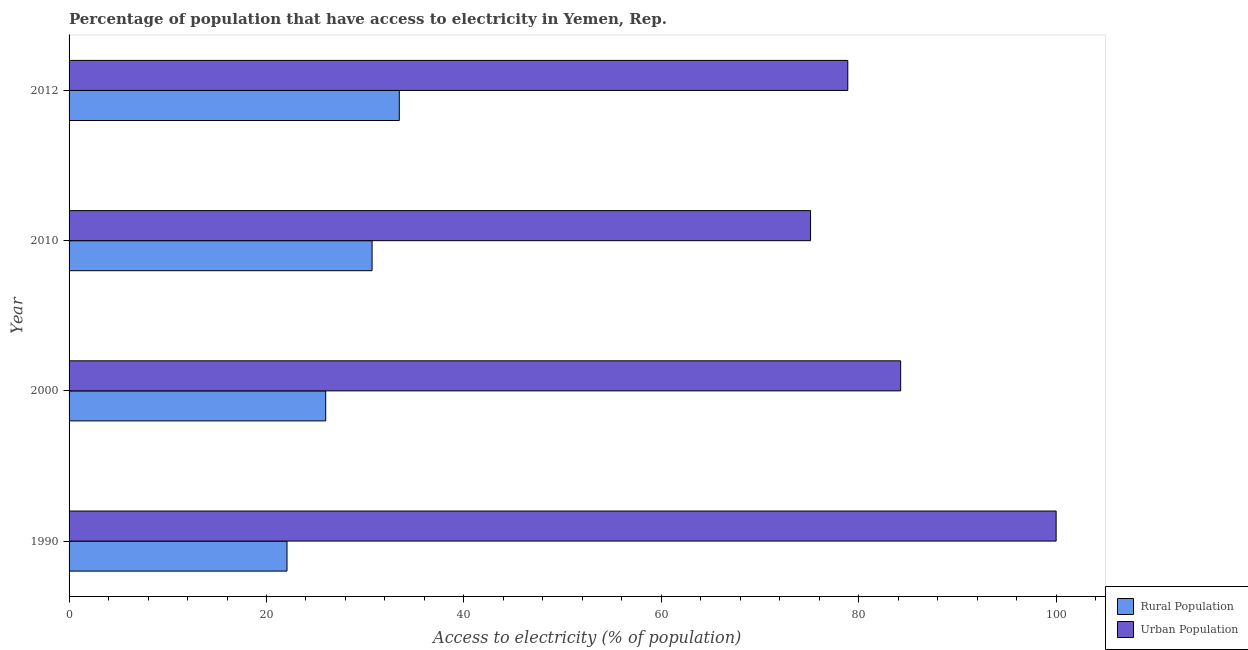How many different coloured bars are there?
Give a very brief answer. 2. How many groups of bars are there?
Offer a very short reply. 4. Are the number of bars per tick equal to the number of legend labels?
Your answer should be very brief. Yes. How many bars are there on the 3rd tick from the bottom?
Your answer should be compact. 2. What is the label of the 1st group of bars from the top?
Your answer should be very brief. 2012. What is the percentage of urban population having access to electricity in 2010?
Offer a very short reply. 75.12. Across all years, what is the maximum percentage of urban population having access to electricity?
Offer a very short reply. 100. Across all years, what is the minimum percentage of rural population having access to electricity?
Provide a succinct answer. 22.08. What is the total percentage of urban population having access to electricity in the graph?
Keep it short and to the point. 338.26. What is the difference between the percentage of urban population having access to electricity in 2010 and that in 2012?
Ensure brevity in your answer.  -3.77. What is the difference between the percentage of rural population having access to electricity in 2000 and the percentage of urban population having access to electricity in 1990?
Your answer should be compact. -74. What is the average percentage of urban population having access to electricity per year?
Offer a terse response. 84.56. In the year 2012, what is the difference between the percentage of urban population having access to electricity and percentage of rural population having access to electricity?
Your answer should be compact. 45.44. In how many years, is the percentage of urban population having access to electricity greater than 84 %?
Your response must be concise. 2. What is the ratio of the percentage of rural population having access to electricity in 1990 to that in 2000?
Provide a succinct answer. 0.85. Is the difference between the percentage of urban population having access to electricity in 1990 and 2010 greater than the difference between the percentage of rural population having access to electricity in 1990 and 2010?
Offer a very short reply. Yes. What is the difference between the highest and the second highest percentage of rural population having access to electricity?
Offer a very short reply. 2.75. What is the difference between the highest and the lowest percentage of urban population having access to electricity?
Your answer should be compact. 24.88. Is the sum of the percentage of rural population having access to electricity in 1990 and 2010 greater than the maximum percentage of urban population having access to electricity across all years?
Your answer should be very brief. No. What does the 1st bar from the top in 1990 represents?
Give a very brief answer. Urban Population. What does the 1st bar from the bottom in 2012 represents?
Your answer should be very brief. Rural Population. How many bars are there?
Offer a terse response. 8. How many years are there in the graph?
Keep it short and to the point. 4. What is the difference between two consecutive major ticks on the X-axis?
Offer a very short reply. 20. Does the graph contain any zero values?
Offer a very short reply. No. Where does the legend appear in the graph?
Make the answer very short. Bottom right. How are the legend labels stacked?
Offer a terse response. Vertical. What is the title of the graph?
Keep it short and to the point. Percentage of population that have access to electricity in Yemen, Rep. Does "Subsidies" appear as one of the legend labels in the graph?
Give a very brief answer. No. What is the label or title of the X-axis?
Your answer should be very brief. Access to electricity (% of population). What is the Access to electricity (% of population) of Rural Population in 1990?
Give a very brief answer. 22.08. What is the Access to electricity (% of population) of Urban Population in 1990?
Make the answer very short. 100. What is the Access to electricity (% of population) of Urban Population in 2000?
Your response must be concise. 84.25. What is the Access to electricity (% of population) in Rural Population in 2010?
Give a very brief answer. 30.7. What is the Access to electricity (% of population) in Urban Population in 2010?
Provide a succinct answer. 75.12. What is the Access to electricity (% of population) of Rural Population in 2012?
Make the answer very short. 33.45. What is the Access to electricity (% of population) of Urban Population in 2012?
Offer a very short reply. 78.89. Across all years, what is the maximum Access to electricity (% of population) in Rural Population?
Give a very brief answer. 33.45. Across all years, what is the maximum Access to electricity (% of population) of Urban Population?
Offer a terse response. 100. Across all years, what is the minimum Access to electricity (% of population) in Rural Population?
Your answer should be compact. 22.08. Across all years, what is the minimum Access to electricity (% of population) in Urban Population?
Provide a short and direct response. 75.12. What is the total Access to electricity (% of population) of Rural Population in the graph?
Make the answer very short. 112.23. What is the total Access to electricity (% of population) in Urban Population in the graph?
Provide a succinct answer. 338.26. What is the difference between the Access to electricity (% of population) in Rural Population in 1990 and that in 2000?
Keep it short and to the point. -3.92. What is the difference between the Access to electricity (% of population) in Urban Population in 1990 and that in 2000?
Make the answer very short. 15.75. What is the difference between the Access to electricity (% of population) in Rural Population in 1990 and that in 2010?
Offer a very short reply. -8.62. What is the difference between the Access to electricity (% of population) of Urban Population in 1990 and that in 2010?
Ensure brevity in your answer.  24.88. What is the difference between the Access to electricity (% of population) in Rural Population in 1990 and that in 2012?
Your response must be concise. -11.38. What is the difference between the Access to electricity (% of population) in Urban Population in 1990 and that in 2012?
Offer a very short reply. 21.11. What is the difference between the Access to electricity (% of population) in Rural Population in 2000 and that in 2010?
Make the answer very short. -4.7. What is the difference between the Access to electricity (% of population) in Urban Population in 2000 and that in 2010?
Make the answer very short. 9.13. What is the difference between the Access to electricity (% of population) in Rural Population in 2000 and that in 2012?
Give a very brief answer. -7.45. What is the difference between the Access to electricity (% of population) of Urban Population in 2000 and that in 2012?
Your answer should be compact. 5.36. What is the difference between the Access to electricity (% of population) of Rural Population in 2010 and that in 2012?
Your answer should be compact. -2.75. What is the difference between the Access to electricity (% of population) of Urban Population in 2010 and that in 2012?
Offer a very short reply. -3.77. What is the difference between the Access to electricity (% of population) in Rural Population in 1990 and the Access to electricity (% of population) in Urban Population in 2000?
Provide a short and direct response. -62.17. What is the difference between the Access to electricity (% of population) in Rural Population in 1990 and the Access to electricity (% of population) in Urban Population in 2010?
Your answer should be compact. -53.04. What is the difference between the Access to electricity (% of population) in Rural Population in 1990 and the Access to electricity (% of population) in Urban Population in 2012?
Give a very brief answer. -56.81. What is the difference between the Access to electricity (% of population) of Rural Population in 2000 and the Access to electricity (% of population) of Urban Population in 2010?
Ensure brevity in your answer.  -49.12. What is the difference between the Access to electricity (% of population) in Rural Population in 2000 and the Access to electricity (% of population) in Urban Population in 2012?
Give a very brief answer. -52.89. What is the difference between the Access to electricity (% of population) of Rural Population in 2010 and the Access to electricity (% of population) of Urban Population in 2012?
Give a very brief answer. -48.19. What is the average Access to electricity (% of population) in Rural Population per year?
Your answer should be very brief. 28.06. What is the average Access to electricity (% of population) in Urban Population per year?
Offer a very short reply. 84.56. In the year 1990, what is the difference between the Access to electricity (% of population) in Rural Population and Access to electricity (% of population) in Urban Population?
Provide a succinct answer. -77.92. In the year 2000, what is the difference between the Access to electricity (% of population) in Rural Population and Access to electricity (% of population) in Urban Population?
Your response must be concise. -58.25. In the year 2010, what is the difference between the Access to electricity (% of population) in Rural Population and Access to electricity (% of population) in Urban Population?
Provide a succinct answer. -44.42. In the year 2012, what is the difference between the Access to electricity (% of population) of Rural Population and Access to electricity (% of population) of Urban Population?
Make the answer very short. -45.44. What is the ratio of the Access to electricity (% of population) of Rural Population in 1990 to that in 2000?
Provide a succinct answer. 0.85. What is the ratio of the Access to electricity (% of population) in Urban Population in 1990 to that in 2000?
Your answer should be very brief. 1.19. What is the ratio of the Access to electricity (% of population) of Rural Population in 1990 to that in 2010?
Give a very brief answer. 0.72. What is the ratio of the Access to electricity (% of population) of Urban Population in 1990 to that in 2010?
Your response must be concise. 1.33. What is the ratio of the Access to electricity (% of population) of Rural Population in 1990 to that in 2012?
Your answer should be compact. 0.66. What is the ratio of the Access to electricity (% of population) in Urban Population in 1990 to that in 2012?
Offer a very short reply. 1.27. What is the ratio of the Access to electricity (% of population) of Rural Population in 2000 to that in 2010?
Your answer should be compact. 0.85. What is the ratio of the Access to electricity (% of population) of Urban Population in 2000 to that in 2010?
Ensure brevity in your answer.  1.12. What is the ratio of the Access to electricity (% of population) of Rural Population in 2000 to that in 2012?
Ensure brevity in your answer.  0.78. What is the ratio of the Access to electricity (% of population) of Urban Population in 2000 to that in 2012?
Provide a succinct answer. 1.07. What is the ratio of the Access to electricity (% of population) in Rural Population in 2010 to that in 2012?
Provide a short and direct response. 0.92. What is the ratio of the Access to electricity (% of population) of Urban Population in 2010 to that in 2012?
Your answer should be very brief. 0.95. What is the difference between the highest and the second highest Access to electricity (% of population) in Rural Population?
Offer a terse response. 2.75. What is the difference between the highest and the second highest Access to electricity (% of population) of Urban Population?
Make the answer very short. 15.75. What is the difference between the highest and the lowest Access to electricity (% of population) of Rural Population?
Give a very brief answer. 11.38. What is the difference between the highest and the lowest Access to electricity (% of population) in Urban Population?
Make the answer very short. 24.88. 